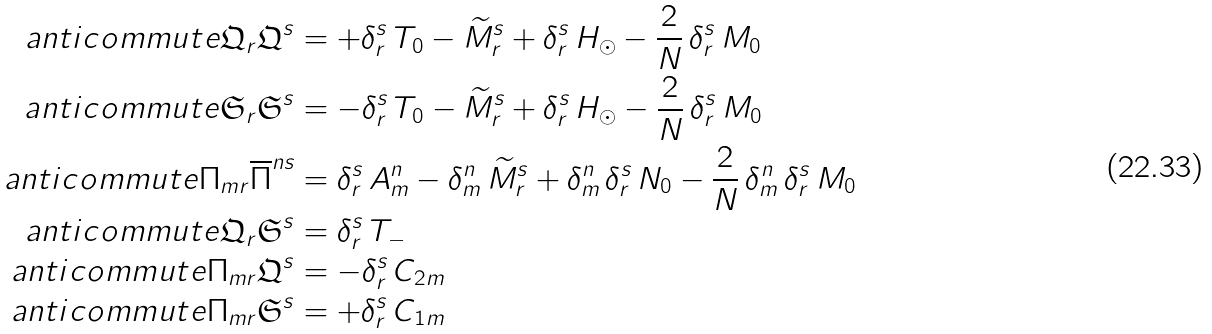Convert formula to latex. <formula><loc_0><loc_0><loc_500><loc_500>\ a n t i c o m m u t e { \mathfrak { Q } _ { r } } { \mathfrak { Q } ^ { s } } & = + \delta ^ { s } _ { r } \, T _ { 0 } - \widetilde { M } ^ { s } _ { r } + \delta ^ { s } _ { r } \, H _ { \odot } - \frac { 2 } { N } \, \delta ^ { s } _ { r } \, M _ { 0 } \\ \ a n t i c o m m u t e { \mathfrak { S } _ { r } } { \mathfrak { S } ^ { s } } & = - \delta ^ { s } _ { r } \, T _ { 0 } - \widetilde { M } ^ { s } _ { r } + \delta ^ { s } _ { r } \, H _ { \odot } - \frac { 2 } { N } \, \delta ^ { s } _ { r } \, M _ { 0 } \\ \ a n t i c o m m u t e { \Pi _ { m r } } { \overline { \Pi } ^ { n s } } & = \delta ^ { s } _ { r } \, A ^ { n } _ { m } - \delta ^ { n } _ { m } \, \widetilde { M } ^ { s } _ { r } + \delta ^ { n } _ { m } \, \delta ^ { s } _ { r } \, N _ { 0 } - \frac { 2 } { N } \, \delta ^ { n } _ { m } \, \delta ^ { s } _ { r } \, M _ { 0 } \\ \ a n t i c o m m u t e { \mathfrak { Q } _ { r } } { \mathfrak { S } ^ { s } } & = \delta ^ { s } _ { r } \, T _ { - } \\ \ a n t i c o m m u t e { \Pi _ { m r } } { \mathfrak { Q } ^ { s } } & = - \delta ^ { s } _ { r } \, C _ { 2 m } \\ \ a n t i c o m m u t e { \Pi _ { m r } } { \mathfrak { S } ^ { s } } & = + \delta ^ { s } _ { r } \, C _ { 1 m }</formula> 